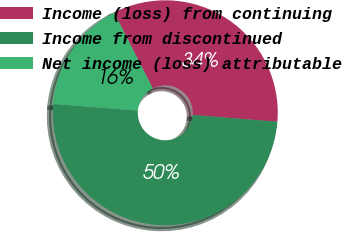Convert chart to OTSL. <chart><loc_0><loc_0><loc_500><loc_500><pie_chart><fcel>Income (loss) from continuing<fcel>Income from discontinued<fcel>Net income (loss) attributable<nl><fcel>33.77%<fcel>50.0%<fcel>16.23%<nl></chart> 